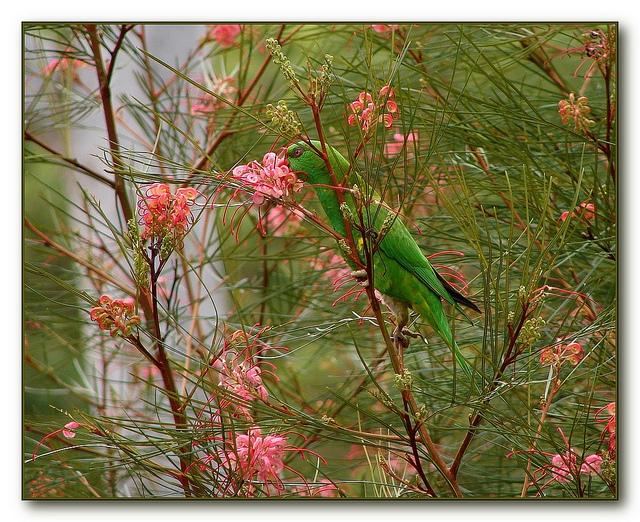Is this bird facing the camera?
Be succinct. No. Is this a real bird?
Give a very brief answer. Yes. Is this bird the same color as the flowers?
Concise answer only. No. 